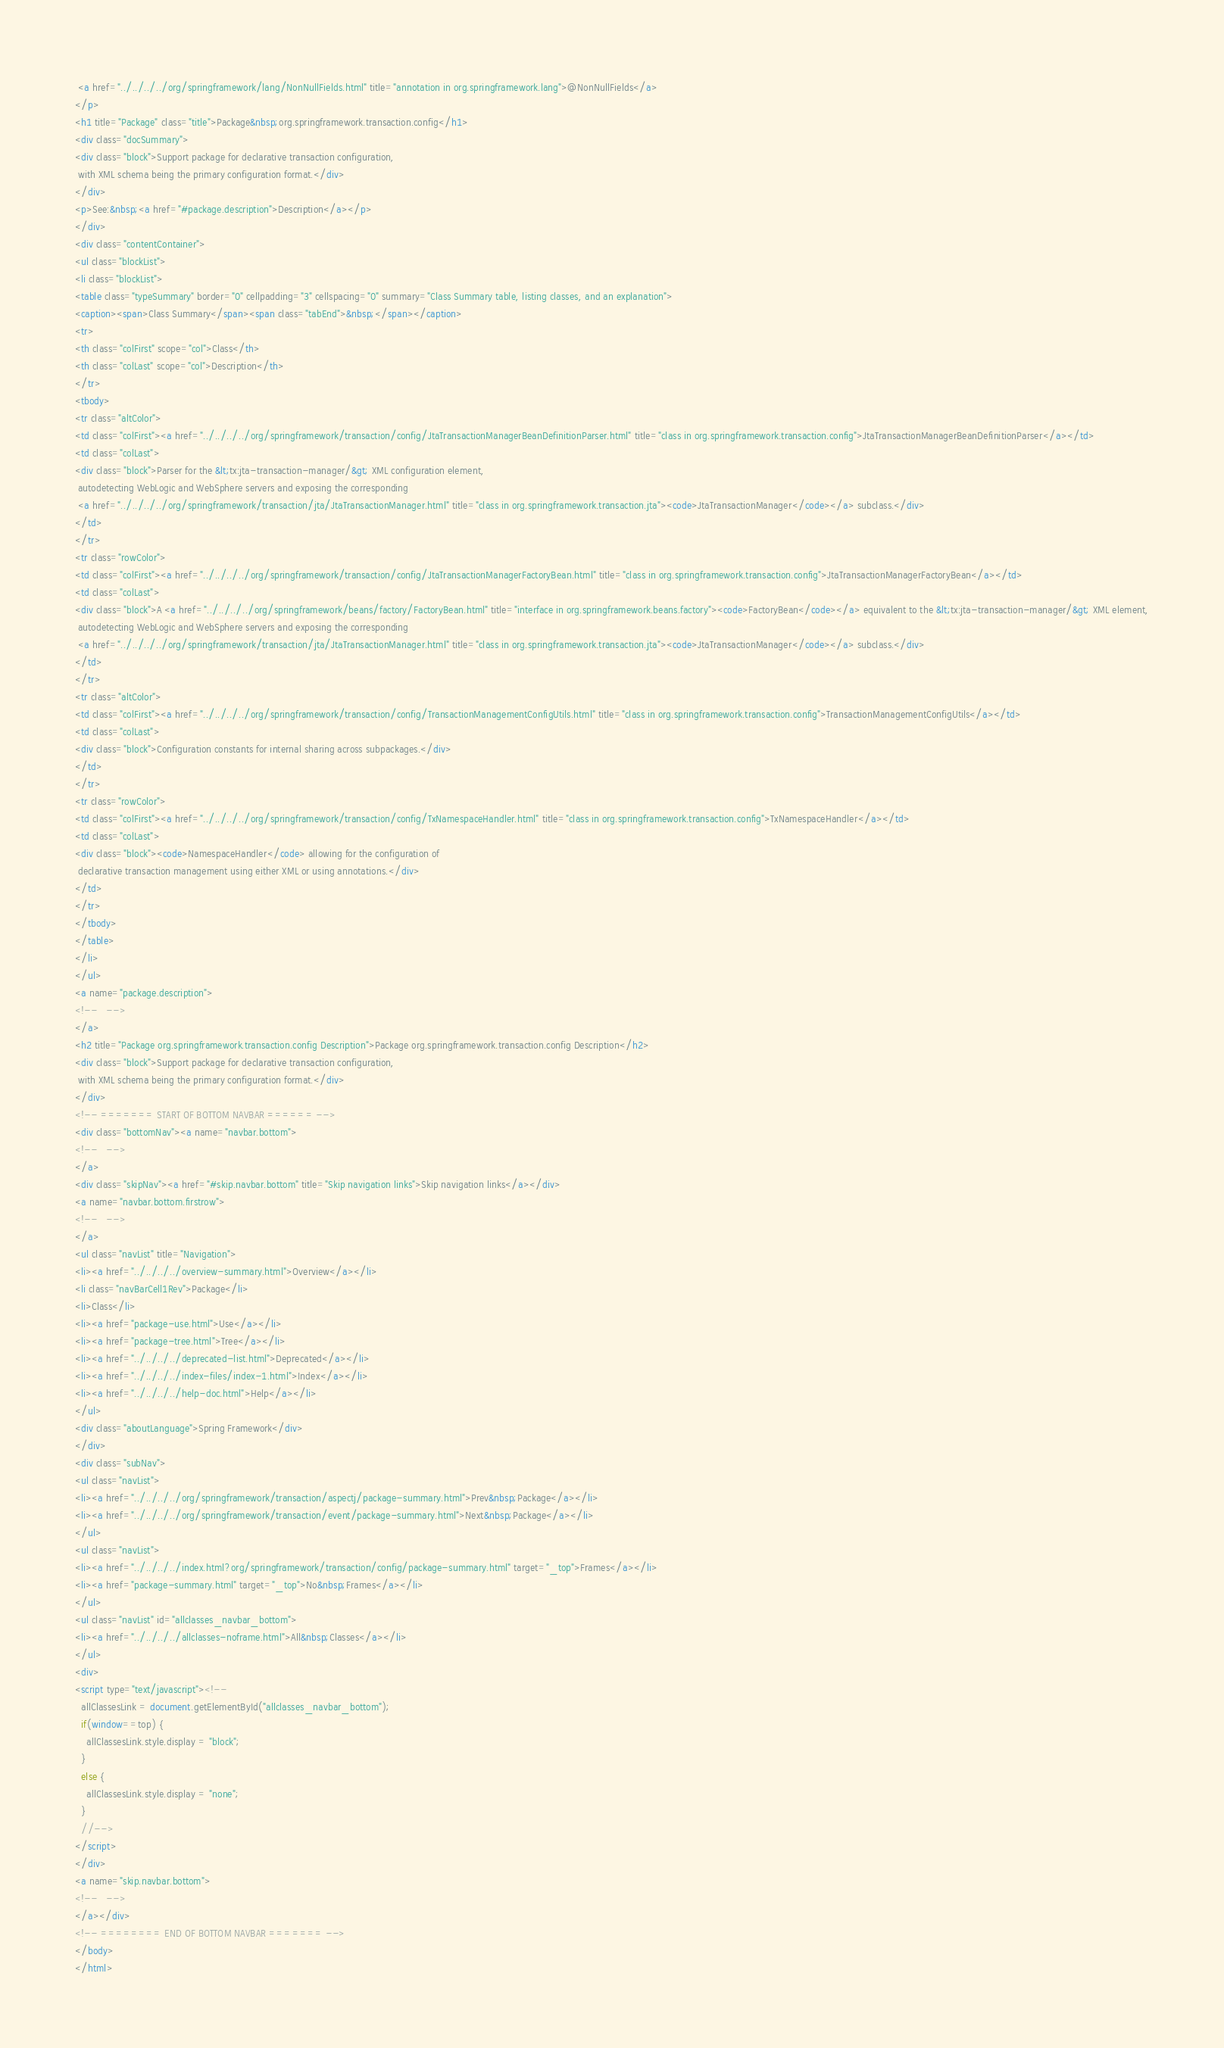Convert code to text. <code><loc_0><loc_0><loc_500><loc_500><_HTML_> <a href="../../../../org/springframework/lang/NonNullFields.html" title="annotation in org.springframework.lang">@NonNullFields</a>
</p>
<h1 title="Package" class="title">Package&nbsp;org.springframework.transaction.config</h1>
<div class="docSummary">
<div class="block">Support package for declarative transaction configuration,
 with XML schema being the primary configuration format.</div>
</div>
<p>See:&nbsp;<a href="#package.description">Description</a></p>
</div>
<div class="contentContainer">
<ul class="blockList">
<li class="blockList">
<table class="typeSummary" border="0" cellpadding="3" cellspacing="0" summary="Class Summary table, listing classes, and an explanation">
<caption><span>Class Summary</span><span class="tabEnd">&nbsp;</span></caption>
<tr>
<th class="colFirst" scope="col">Class</th>
<th class="colLast" scope="col">Description</th>
</tr>
<tbody>
<tr class="altColor">
<td class="colFirst"><a href="../../../../org/springframework/transaction/config/JtaTransactionManagerBeanDefinitionParser.html" title="class in org.springframework.transaction.config">JtaTransactionManagerBeanDefinitionParser</a></td>
<td class="colLast">
<div class="block">Parser for the &lt;tx:jta-transaction-manager/&gt; XML configuration element,
 autodetecting WebLogic and WebSphere servers and exposing the corresponding
 <a href="../../../../org/springframework/transaction/jta/JtaTransactionManager.html" title="class in org.springframework.transaction.jta"><code>JtaTransactionManager</code></a> subclass.</div>
</td>
</tr>
<tr class="rowColor">
<td class="colFirst"><a href="../../../../org/springframework/transaction/config/JtaTransactionManagerFactoryBean.html" title="class in org.springframework.transaction.config">JtaTransactionManagerFactoryBean</a></td>
<td class="colLast">
<div class="block">A <a href="../../../../org/springframework/beans/factory/FactoryBean.html" title="interface in org.springframework.beans.factory"><code>FactoryBean</code></a> equivalent to the &lt;tx:jta-transaction-manager/&gt; XML element,
 autodetecting WebLogic and WebSphere servers and exposing the corresponding
 <a href="../../../../org/springframework/transaction/jta/JtaTransactionManager.html" title="class in org.springframework.transaction.jta"><code>JtaTransactionManager</code></a> subclass.</div>
</td>
</tr>
<tr class="altColor">
<td class="colFirst"><a href="../../../../org/springframework/transaction/config/TransactionManagementConfigUtils.html" title="class in org.springframework.transaction.config">TransactionManagementConfigUtils</a></td>
<td class="colLast">
<div class="block">Configuration constants for internal sharing across subpackages.</div>
</td>
</tr>
<tr class="rowColor">
<td class="colFirst"><a href="../../../../org/springframework/transaction/config/TxNamespaceHandler.html" title="class in org.springframework.transaction.config">TxNamespaceHandler</a></td>
<td class="colLast">
<div class="block"><code>NamespaceHandler</code> allowing for the configuration of
 declarative transaction management using either XML or using annotations.</div>
</td>
</tr>
</tbody>
</table>
</li>
</ul>
<a name="package.description">
<!--   -->
</a>
<h2 title="Package org.springframework.transaction.config Description">Package org.springframework.transaction.config Description</h2>
<div class="block">Support package for declarative transaction configuration,
 with XML schema being the primary configuration format.</div>
</div>
<!-- ======= START OF BOTTOM NAVBAR ====== -->
<div class="bottomNav"><a name="navbar.bottom">
<!--   -->
</a>
<div class="skipNav"><a href="#skip.navbar.bottom" title="Skip navigation links">Skip navigation links</a></div>
<a name="navbar.bottom.firstrow">
<!--   -->
</a>
<ul class="navList" title="Navigation">
<li><a href="../../../../overview-summary.html">Overview</a></li>
<li class="navBarCell1Rev">Package</li>
<li>Class</li>
<li><a href="package-use.html">Use</a></li>
<li><a href="package-tree.html">Tree</a></li>
<li><a href="../../../../deprecated-list.html">Deprecated</a></li>
<li><a href="../../../../index-files/index-1.html">Index</a></li>
<li><a href="../../../../help-doc.html">Help</a></li>
</ul>
<div class="aboutLanguage">Spring Framework</div>
</div>
<div class="subNav">
<ul class="navList">
<li><a href="../../../../org/springframework/transaction/aspectj/package-summary.html">Prev&nbsp;Package</a></li>
<li><a href="../../../../org/springframework/transaction/event/package-summary.html">Next&nbsp;Package</a></li>
</ul>
<ul class="navList">
<li><a href="../../../../index.html?org/springframework/transaction/config/package-summary.html" target="_top">Frames</a></li>
<li><a href="package-summary.html" target="_top">No&nbsp;Frames</a></li>
</ul>
<ul class="navList" id="allclasses_navbar_bottom">
<li><a href="../../../../allclasses-noframe.html">All&nbsp;Classes</a></li>
</ul>
<div>
<script type="text/javascript"><!--
  allClassesLink = document.getElementById("allclasses_navbar_bottom");
  if(window==top) {
    allClassesLink.style.display = "block";
  }
  else {
    allClassesLink.style.display = "none";
  }
  //-->
</script>
</div>
<a name="skip.navbar.bottom">
<!--   -->
</a></div>
<!-- ======== END OF BOTTOM NAVBAR ======= -->
</body>
</html>
</code> 